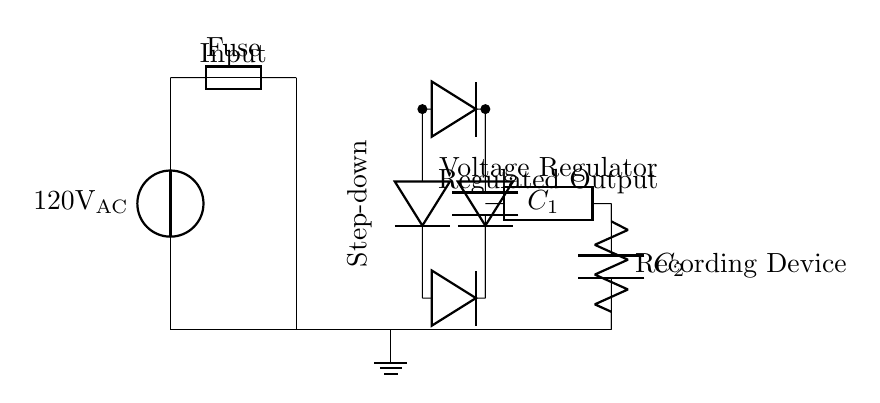What is the input voltage of this circuit? The input voltage is specified as 120 volts AC, which is shown next to the voltage source in the circuit.
Answer: 120 volts AC What component is used for voltage regulation in this circuit? The voltage regulator is indicated in the diagram as a generic component labeled "Voltage Regulator," connected after the capacitor.
Answer: Voltage Regulator How many diodes are used in the rectifier section? There are four diodes located between the two points labeled for the rectifier, used to convert AC to DC.
Answer: Four What is the purpose of capacitor C1 in this circuit? Capacitor C1, shown in the circuit after the rectifier, is used for smoothing out the rectified voltage, making it more stable for the subsequent regulation.
Answer: Smoothing What type of device is represented at the output of this circuit? The output of the circuit shows a "Recording Device," indicating that this circuit is designed to power sensitive recording equipment.
Answer: Recording Device What is the configuration of the transformer in this circuit? The transformer is labeled as "Step-down," indicating that it reduces the input voltage before it reaches the rectifier.
Answer: Step-down What is the purpose of the fuse in this circuit? The fuse is included in the circuit as a safety device to prevent overloads by breaking the circuit if the current exceeds a specified limit.
Answer: Safety device 